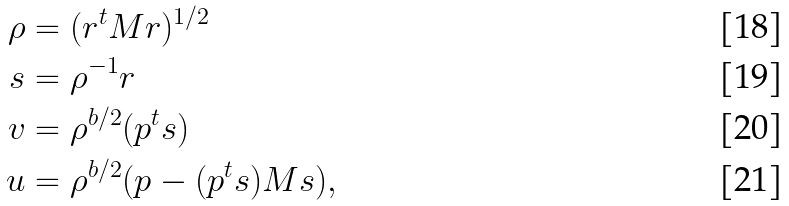Convert formula to latex. <formula><loc_0><loc_0><loc_500><loc_500>\rho & = ( { r } ^ { t } M { r } ) ^ { 1 / 2 } \\ s & = \rho ^ { - 1 } { r } \\ v & = \rho ^ { b / 2 } ( { p } ^ { t } { s } ) \\ u & = \rho ^ { b / 2 } ( { p } - ( { p } ^ { t } { s } ) M { s } ) ,</formula> 